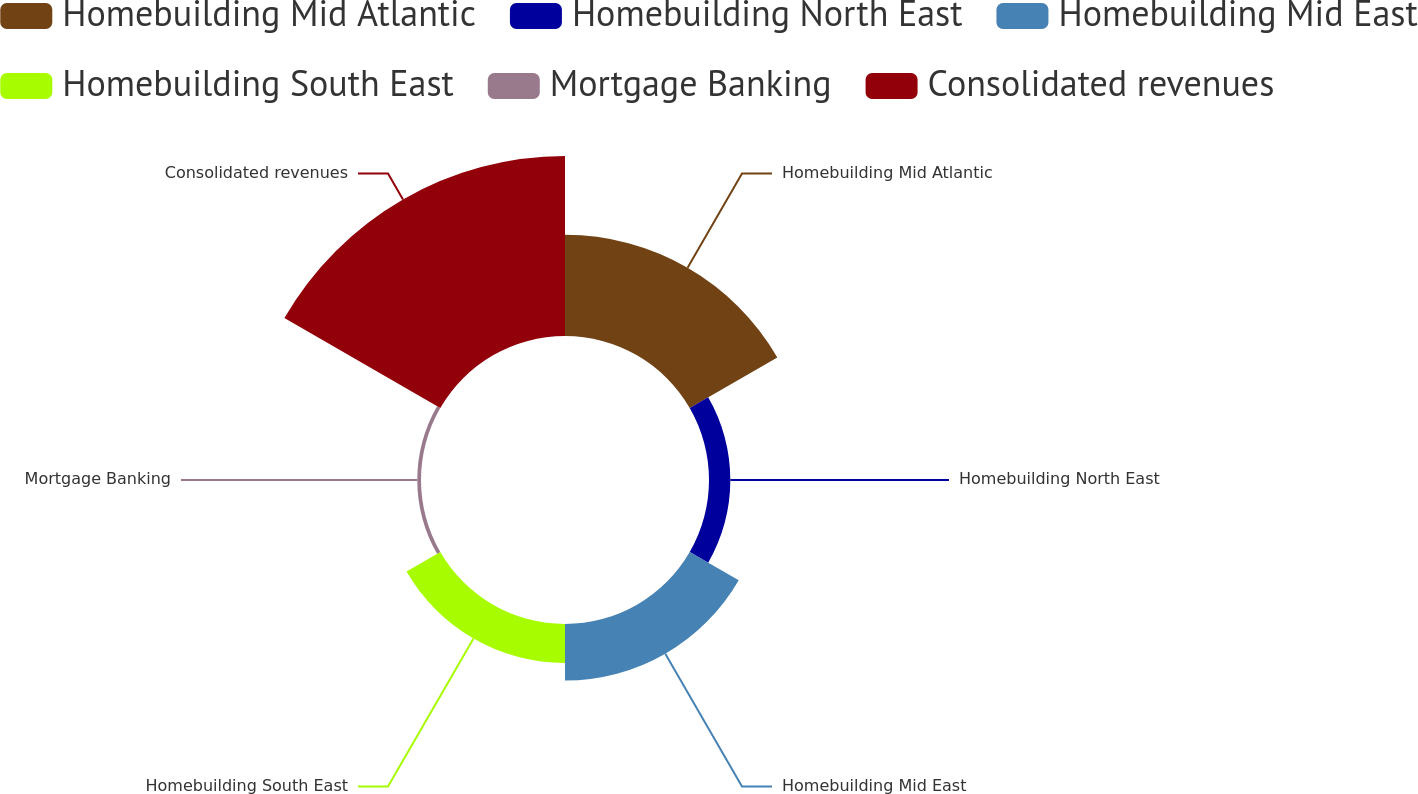<chart> <loc_0><loc_0><loc_500><loc_500><pie_chart><fcel>Homebuilding Mid Atlantic<fcel>Homebuilding North East<fcel>Homebuilding Mid East<fcel>Homebuilding South East<fcel>Mortgage Banking<fcel>Consolidated revenues<nl><fcel>25.18%<fcel>5.31%<fcel>14.09%<fcel>9.7%<fcel>0.93%<fcel>44.8%<nl></chart> 